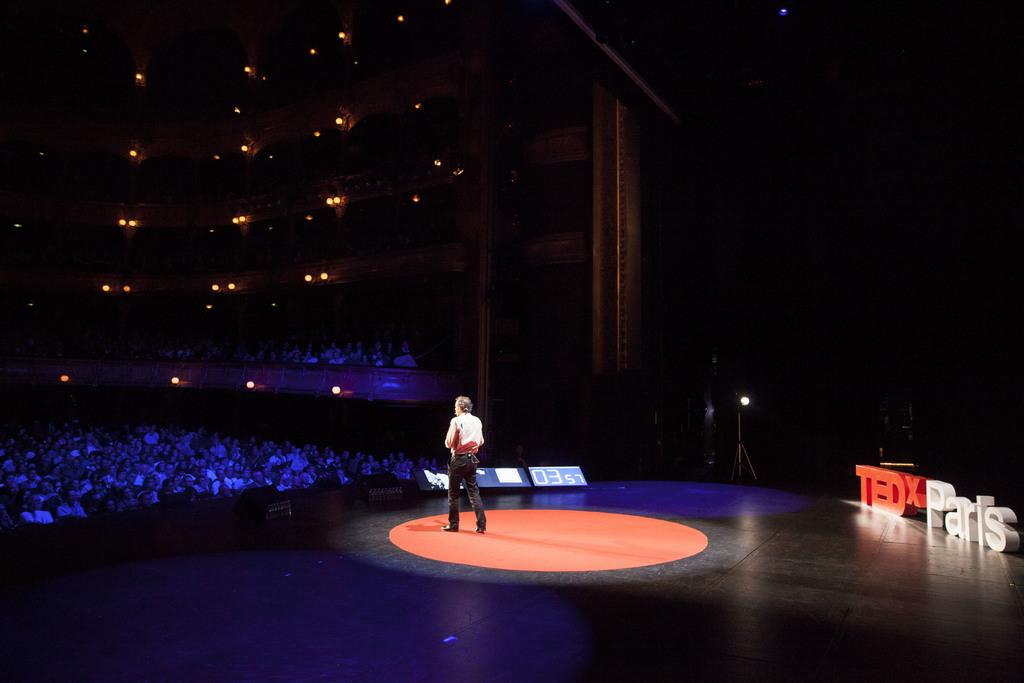What is the man doing in the image? The man is standing on the stage. Where are the people located in the image? The people are sitting on the left side of the image. What can be seen at the top of the image? There are lights visible at the top of the image. What type of rice is being served to the audience in the image? There is no rice present in the image. What is the weather like during the event in the image? The provided facts do not mention the weather, so we cannot determine the weather from the image. 